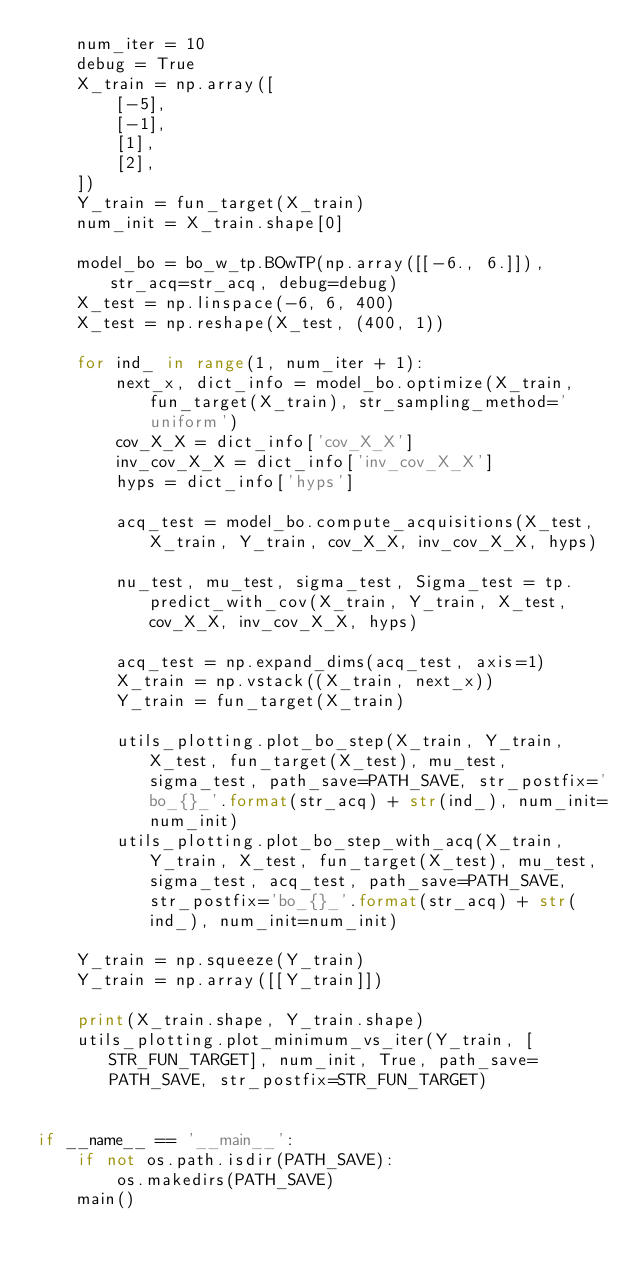<code> <loc_0><loc_0><loc_500><loc_500><_Python_>    num_iter = 10
    debug = True
    X_train = np.array([
        [-5],
        [-1],
        [1],
        [2],
    ])
    Y_train = fun_target(X_train)
    num_init = X_train.shape[0]

    model_bo = bo_w_tp.BOwTP(np.array([[-6., 6.]]), str_acq=str_acq, debug=debug)
    X_test = np.linspace(-6, 6, 400)
    X_test = np.reshape(X_test, (400, 1))

    for ind_ in range(1, num_iter + 1):
        next_x, dict_info = model_bo.optimize(X_train, fun_target(X_train), str_sampling_method='uniform')
        cov_X_X = dict_info['cov_X_X']
        inv_cov_X_X = dict_info['inv_cov_X_X']
        hyps = dict_info['hyps']

        acq_test = model_bo.compute_acquisitions(X_test, X_train, Y_train, cov_X_X, inv_cov_X_X, hyps)

        nu_test, mu_test, sigma_test, Sigma_test = tp.predict_with_cov(X_train, Y_train, X_test, cov_X_X, inv_cov_X_X, hyps)

        acq_test = np.expand_dims(acq_test, axis=1)
        X_train = np.vstack((X_train, next_x))
        Y_train = fun_target(X_train)

        utils_plotting.plot_bo_step(X_train, Y_train, X_test, fun_target(X_test), mu_test, sigma_test, path_save=PATH_SAVE, str_postfix='bo_{}_'.format(str_acq) + str(ind_), num_init=num_init)
        utils_plotting.plot_bo_step_with_acq(X_train, Y_train, X_test, fun_target(X_test), mu_test, sigma_test, acq_test, path_save=PATH_SAVE, str_postfix='bo_{}_'.format(str_acq) + str(ind_), num_init=num_init)

    Y_train = np.squeeze(Y_train)
    Y_train = np.array([[Y_train]])

    print(X_train.shape, Y_train.shape)
    utils_plotting.plot_minimum_vs_iter(Y_train, [STR_FUN_TARGET], num_init, True, path_save=PATH_SAVE, str_postfix=STR_FUN_TARGET)


if __name__ == '__main__':
    if not os.path.isdir(PATH_SAVE):
        os.makedirs(PATH_SAVE)
    main()
</code> 